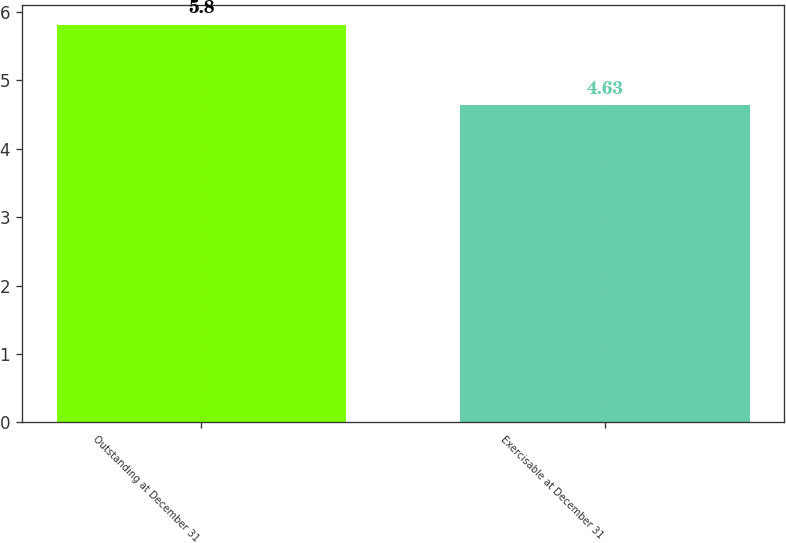<chart> <loc_0><loc_0><loc_500><loc_500><bar_chart><fcel>Outstanding at December 31<fcel>Exercisable at December 31<nl><fcel>5.8<fcel>4.63<nl></chart> 